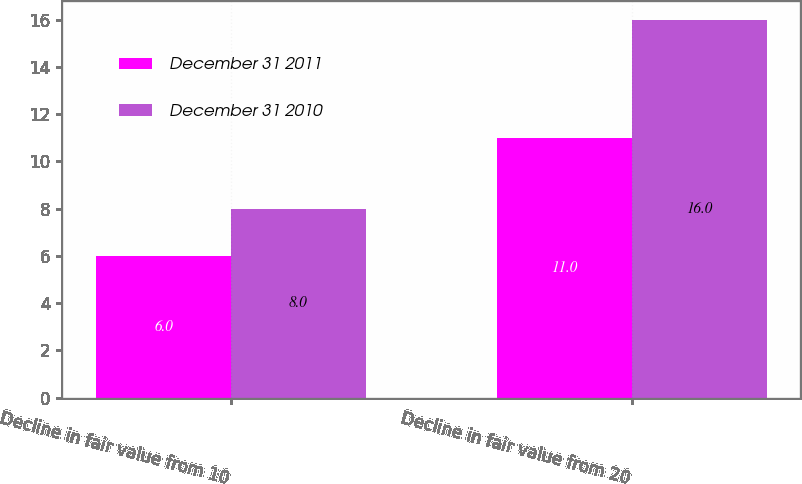<chart> <loc_0><loc_0><loc_500><loc_500><stacked_bar_chart><ecel><fcel>Decline in fair value from 10<fcel>Decline in fair value from 20<nl><fcel>December 31 2011<fcel>6<fcel>11<nl><fcel>December 31 2010<fcel>8<fcel>16<nl></chart> 